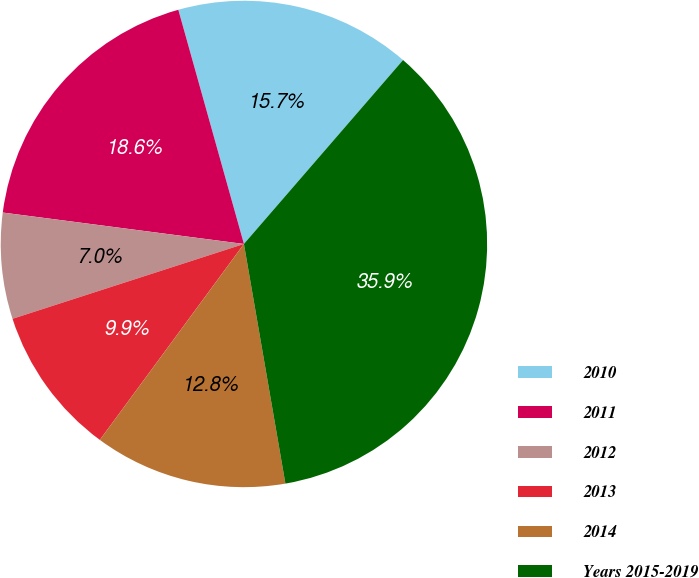<chart> <loc_0><loc_0><loc_500><loc_500><pie_chart><fcel>2010<fcel>2011<fcel>2012<fcel>2013<fcel>2014<fcel>Years 2015-2019<nl><fcel>15.7%<fcel>18.59%<fcel>7.04%<fcel>9.93%<fcel>12.82%<fcel>35.92%<nl></chart> 